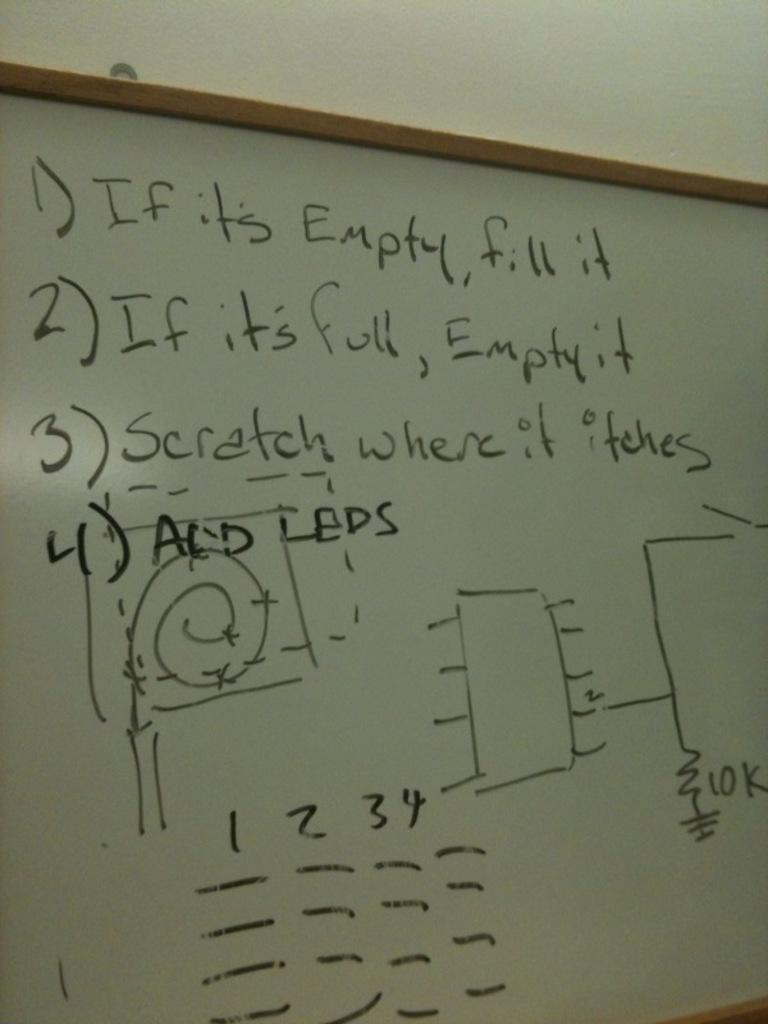<image>
Offer a succinct explanation of the picture presented. A white board says if it is empty, fill it. 